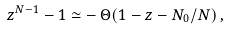<formula> <loc_0><loc_0><loc_500><loc_500>z ^ { N - 1 } - 1 \simeq - \, \Theta ( 1 - z - N _ { 0 } / N ) \, ,</formula> 